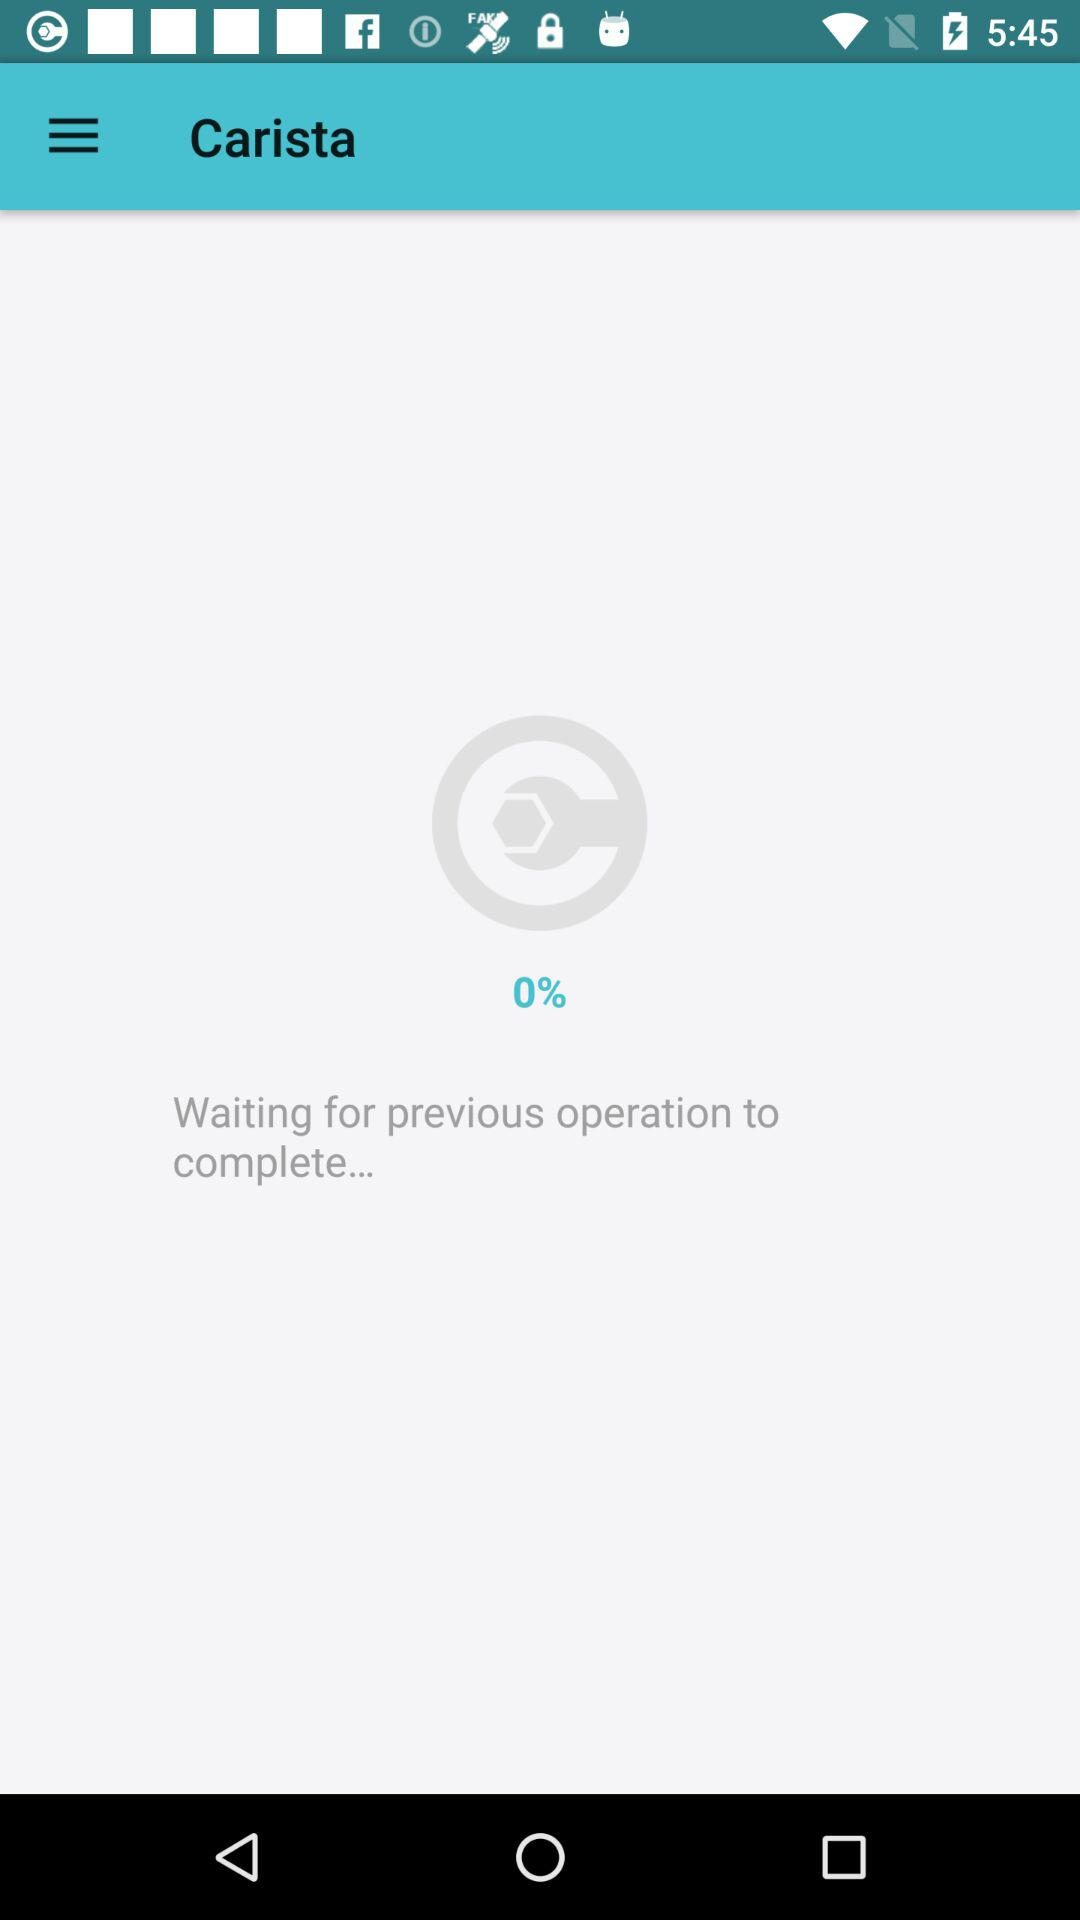What is the percentage of the operation that has completed?
Answer the question using a single word or phrase. 0% 